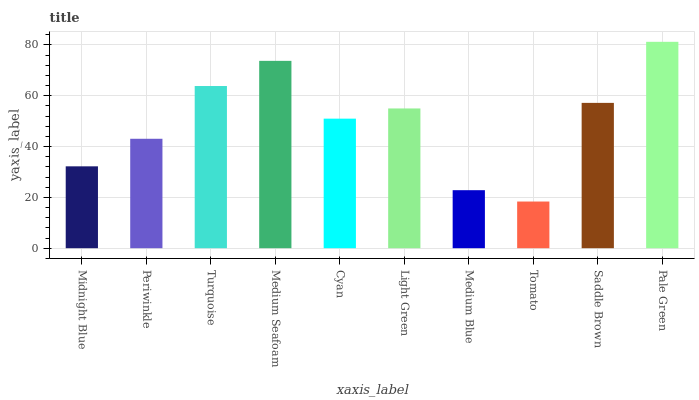Is Tomato the minimum?
Answer yes or no. Yes. Is Pale Green the maximum?
Answer yes or no. Yes. Is Periwinkle the minimum?
Answer yes or no. No. Is Periwinkle the maximum?
Answer yes or no. No. Is Periwinkle greater than Midnight Blue?
Answer yes or no. Yes. Is Midnight Blue less than Periwinkle?
Answer yes or no. Yes. Is Midnight Blue greater than Periwinkle?
Answer yes or no. No. Is Periwinkle less than Midnight Blue?
Answer yes or no. No. Is Light Green the high median?
Answer yes or no. Yes. Is Cyan the low median?
Answer yes or no. Yes. Is Periwinkle the high median?
Answer yes or no. No. Is Periwinkle the low median?
Answer yes or no. No. 